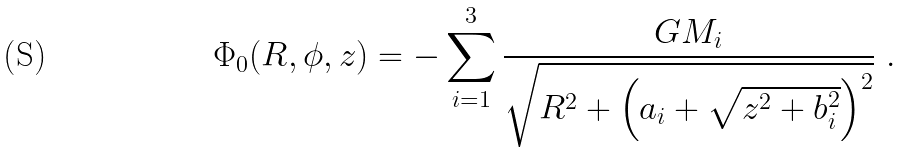Convert formula to latex. <formula><loc_0><loc_0><loc_500><loc_500>\Phi _ { 0 } ( R , \phi , z ) = - \sum _ { i = 1 } ^ { 3 } \frac { G M _ { i } } { \sqrt { R ^ { 2 } + \left ( a _ { i } + \sqrt { z ^ { 2 } + b _ { i } ^ { 2 } } \right ) ^ { 2 } } } \ .</formula> 